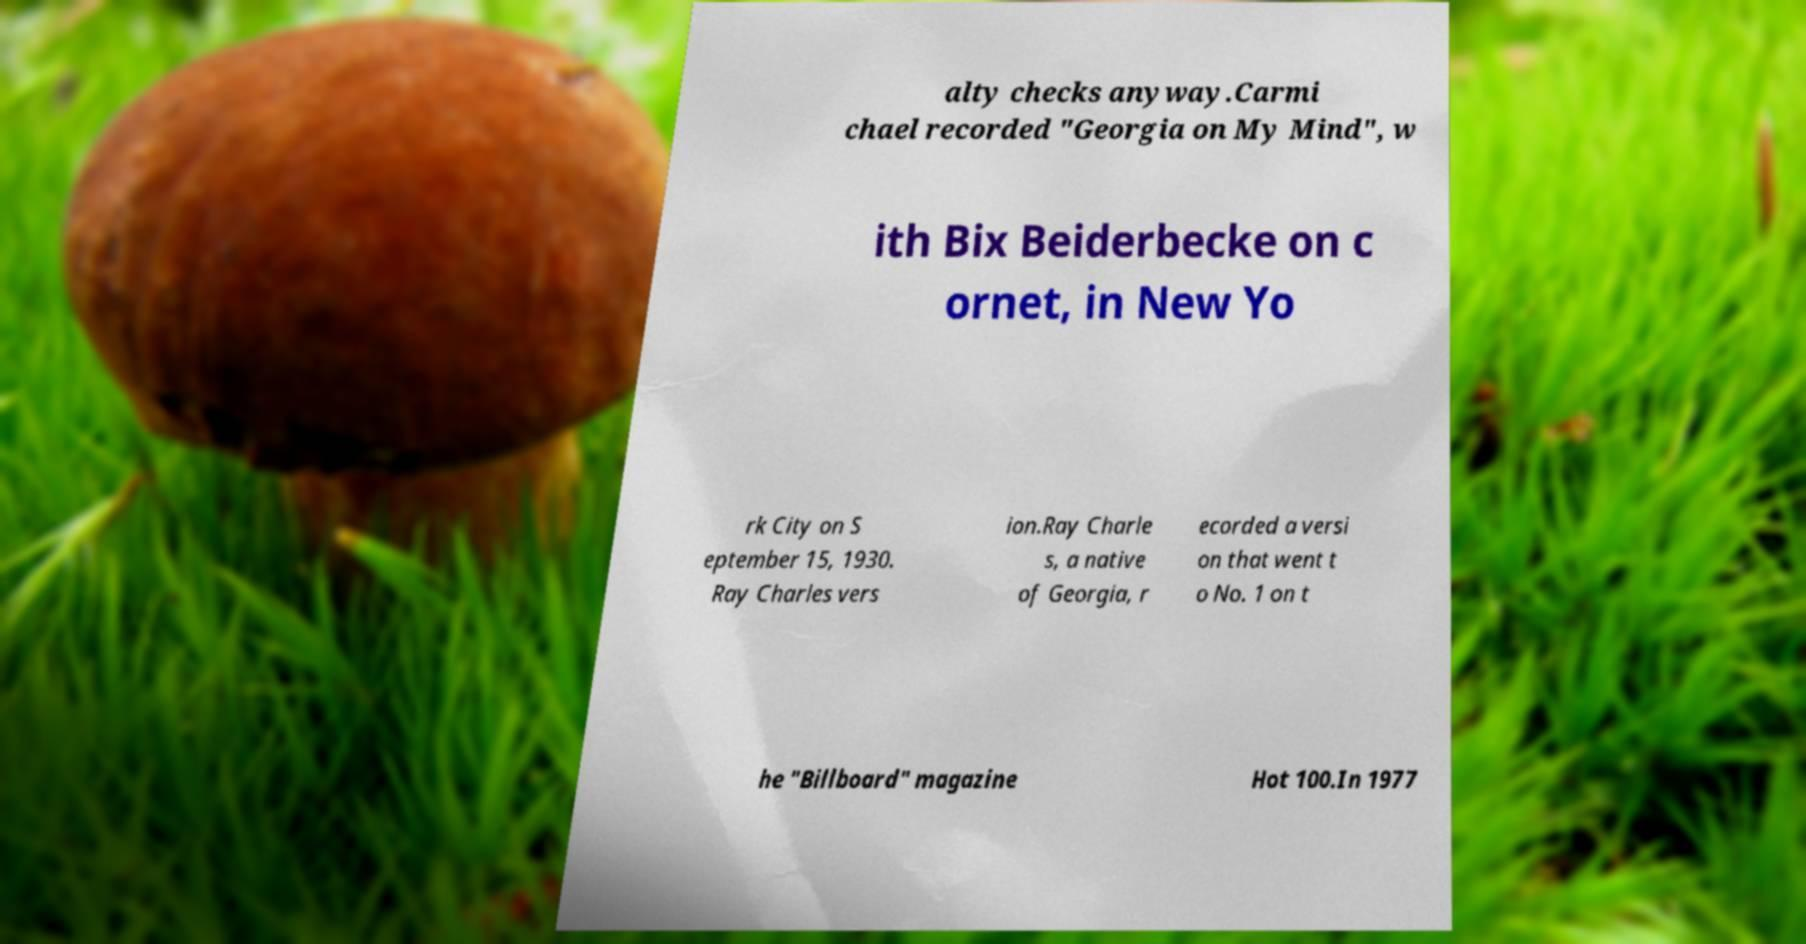What messages or text are displayed in this image? I need them in a readable, typed format. alty checks anyway.Carmi chael recorded "Georgia on My Mind", w ith Bix Beiderbecke on c ornet, in New Yo rk City on S eptember 15, 1930. Ray Charles vers ion.Ray Charle s, a native of Georgia, r ecorded a versi on that went t o No. 1 on t he "Billboard" magazine Hot 100.In 1977 